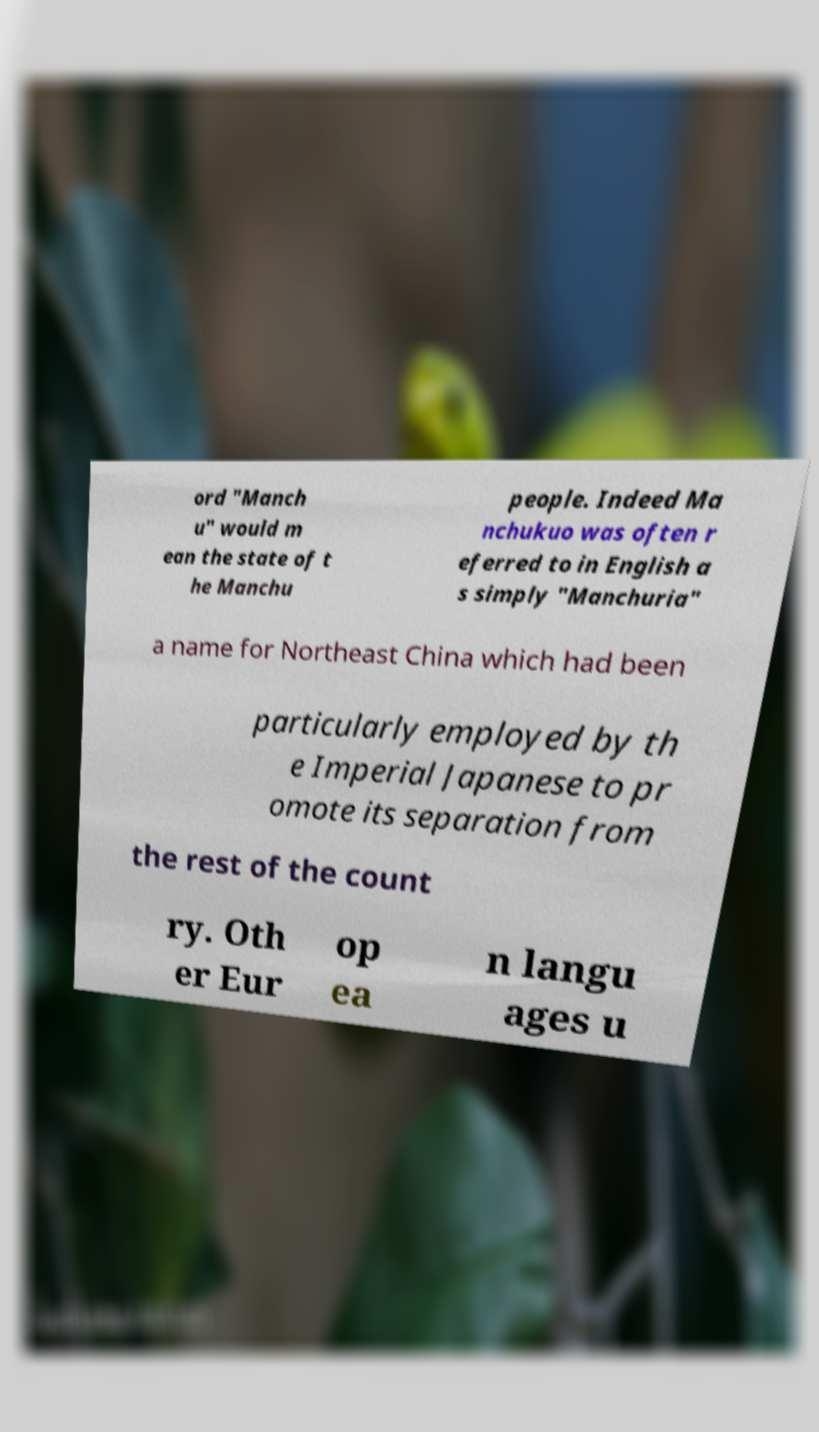Can you accurately transcribe the text from the provided image for me? ord "Manch u" would m ean the state of t he Manchu people. Indeed Ma nchukuo was often r eferred to in English a s simply "Manchuria" a name for Northeast China which had been particularly employed by th e Imperial Japanese to pr omote its separation from the rest of the count ry. Oth er Eur op ea n langu ages u 